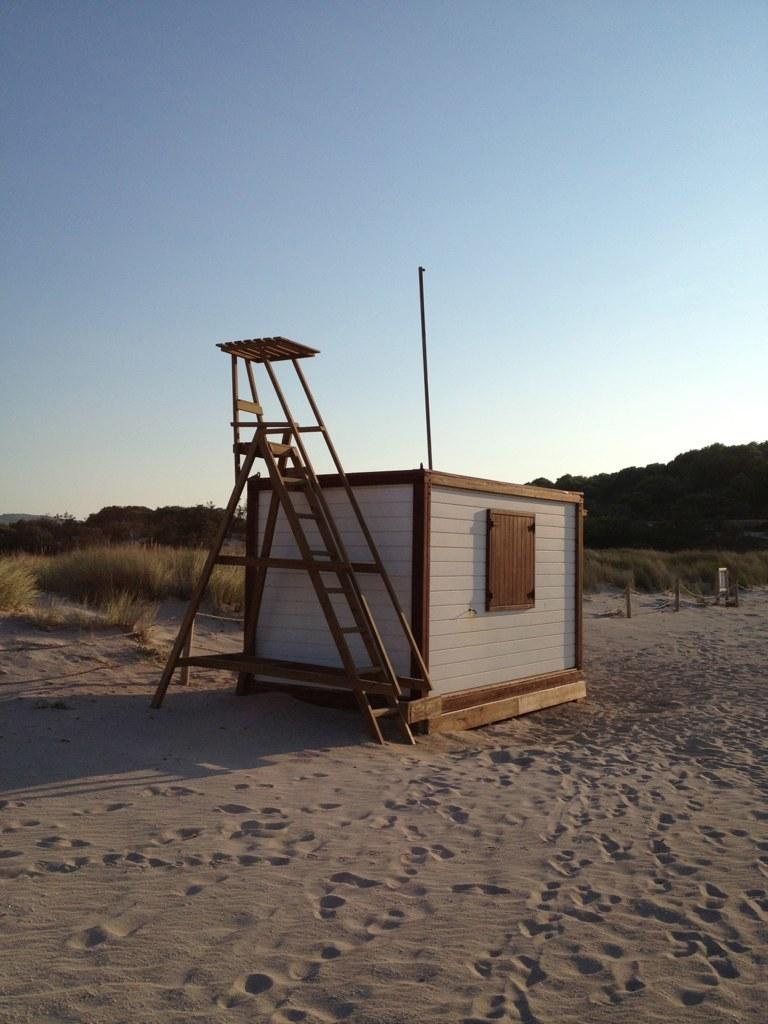What is located in the center of the picture? There are ladders and a room in the center of the picture. What can be seen in the foreground of the image? There is sand in the foreground of the image. What type of vegetation is visible in the background of the image? There are plants, grass, and trees in the background of the image. What is the weather like in the image? The sky is clear and it is sunny in the image. What book is the pet reading in the image? There is no pet or book present in the image. How does the land look like in the image? The image does not show any specific land features; it only shows sand, plants, grass, trees, and a room with ladders. 